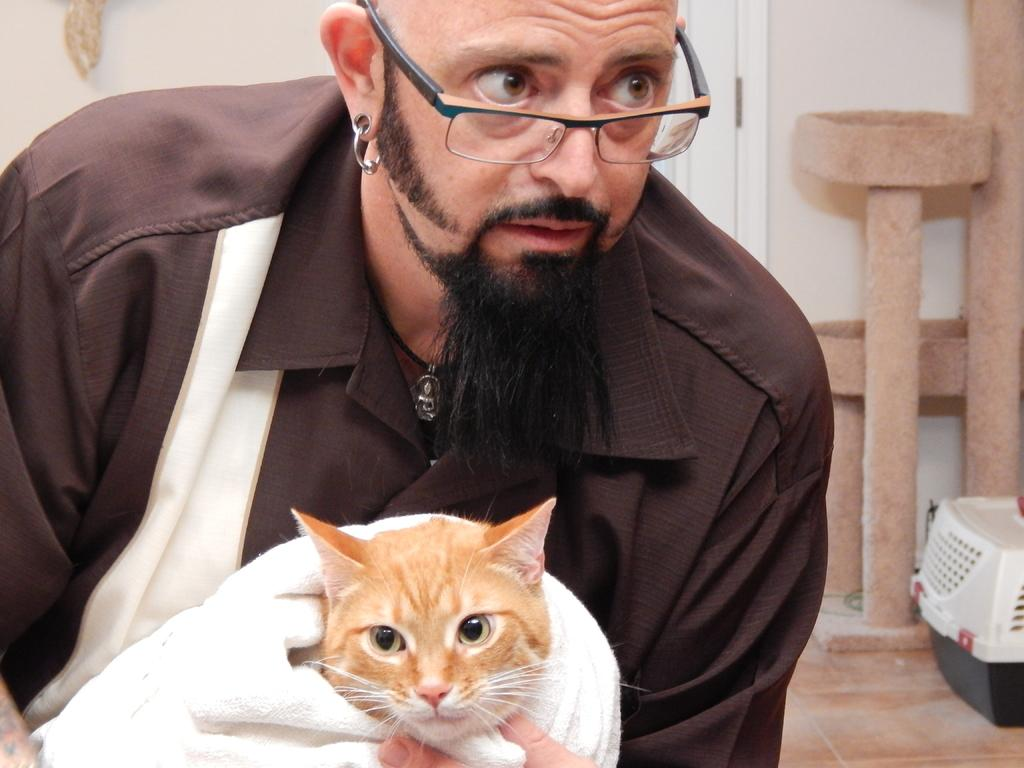What is the man in the image holding? The man is holding a cat in the image. What is the cat sitting on? The cat is on a white towel in the image. What can be seen in the background of the image? There is a door and a wall in the background of the image. What is on the floor in the image? There is a cage on the floor in the image. Can you tell me how many spoonfuls of sugar the man is adding to the cat's food in the image? There is no spoon or sugar present in the image; the man is holding a cat. How many ladybugs are crawling on the wall in the image? There are no ladybugs visible in the image; the background features a door and a wall. 